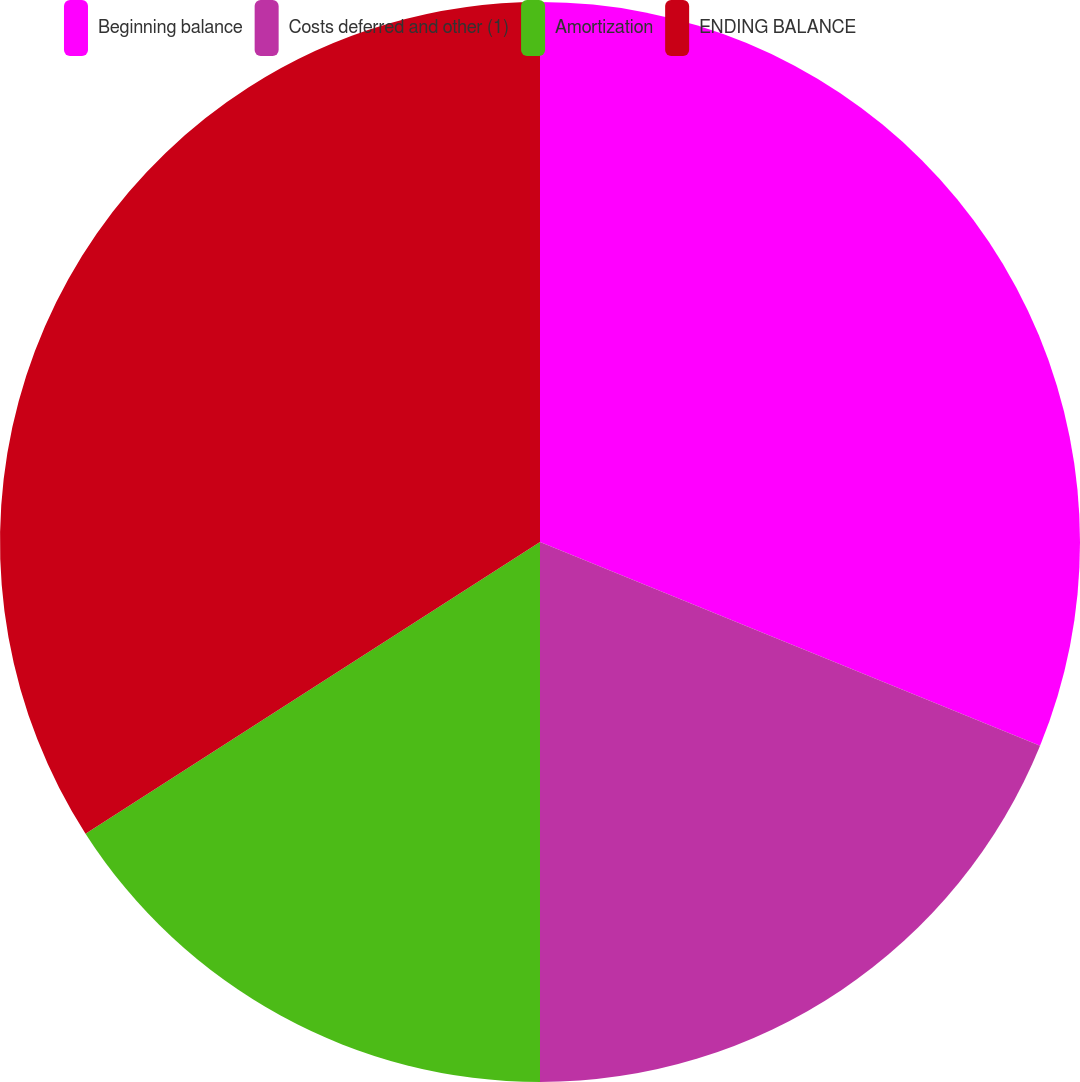Convert chart. <chart><loc_0><loc_0><loc_500><loc_500><pie_chart><fcel>Beginning balance<fcel>Costs deferred and other (1)<fcel>Amortization<fcel>ENDING BALANCE<nl><fcel>31.16%<fcel>18.84%<fcel>15.92%<fcel>34.08%<nl></chart> 